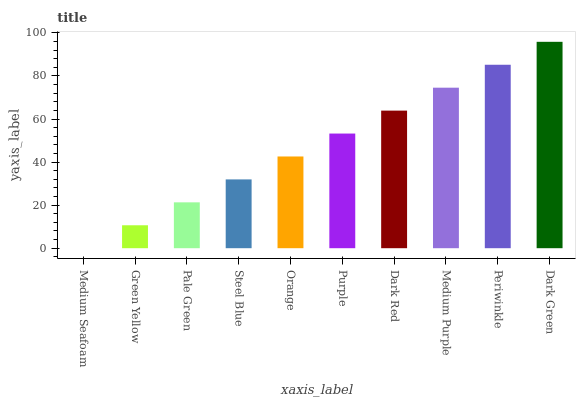Is Medium Seafoam the minimum?
Answer yes or no. Yes. Is Dark Green the maximum?
Answer yes or no. Yes. Is Green Yellow the minimum?
Answer yes or no. No. Is Green Yellow the maximum?
Answer yes or no. No. Is Green Yellow greater than Medium Seafoam?
Answer yes or no. Yes. Is Medium Seafoam less than Green Yellow?
Answer yes or no. Yes. Is Medium Seafoam greater than Green Yellow?
Answer yes or no. No. Is Green Yellow less than Medium Seafoam?
Answer yes or no. No. Is Purple the high median?
Answer yes or no. Yes. Is Orange the low median?
Answer yes or no. Yes. Is Dark Green the high median?
Answer yes or no. No. Is Medium Purple the low median?
Answer yes or no. No. 